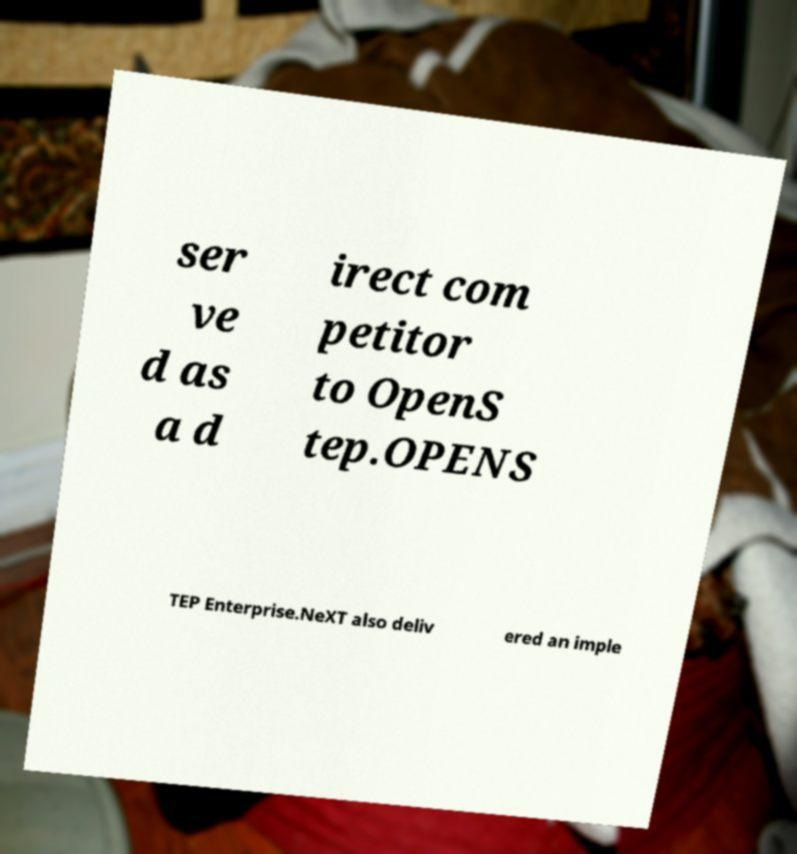There's text embedded in this image that I need extracted. Can you transcribe it verbatim? ser ve d as a d irect com petitor to OpenS tep.OPENS TEP Enterprise.NeXT also deliv ered an imple 